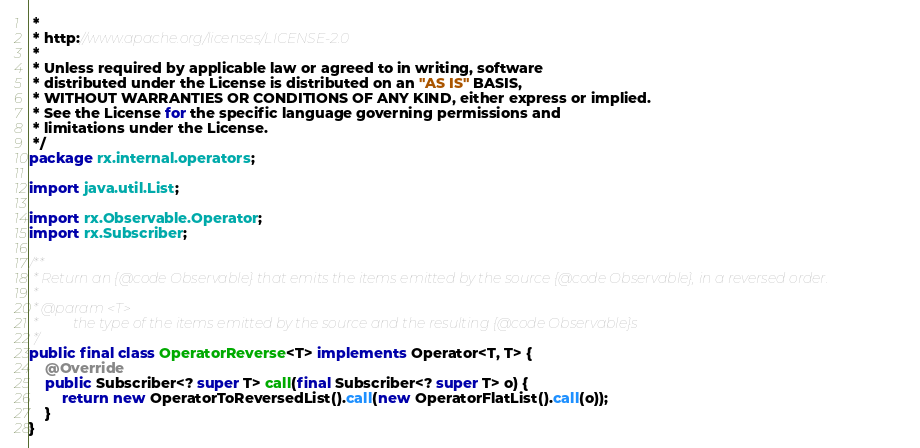<code> <loc_0><loc_0><loc_500><loc_500><_Java_> *
 * http://www.apache.org/licenses/LICENSE-2.0
 *
 * Unless required by applicable law or agreed to in writing, software
 * distributed under the License is distributed on an "AS IS" BASIS,
 * WITHOUT WARRANTIES OR CONDITIONS OF ANY KIND, either express or implied.
 * See the License for the specific language governing permissions and
 * limitations under the License.
 */
package rx.internal.operators;

import java.util.List;

import rx.Observable.Operator;
import rx.Subscriber;

/**
 * Return an {@code Observable} that emits the items emitted by the source {@code Observable}, in a reversed order.
 *
 * @param <T>
 *          the type of the items emitted by the source and the resulting {@code Observable}s
 */
public final class OperatorReverse<T> implements Operator<T, T> {
    @Override
    public Subscriber<? super T> call(final Subscriber<? super T> o) {
        return new OperatorToReversedList().call(new OperatorFlatList().call(o));
    }
}
</code> 